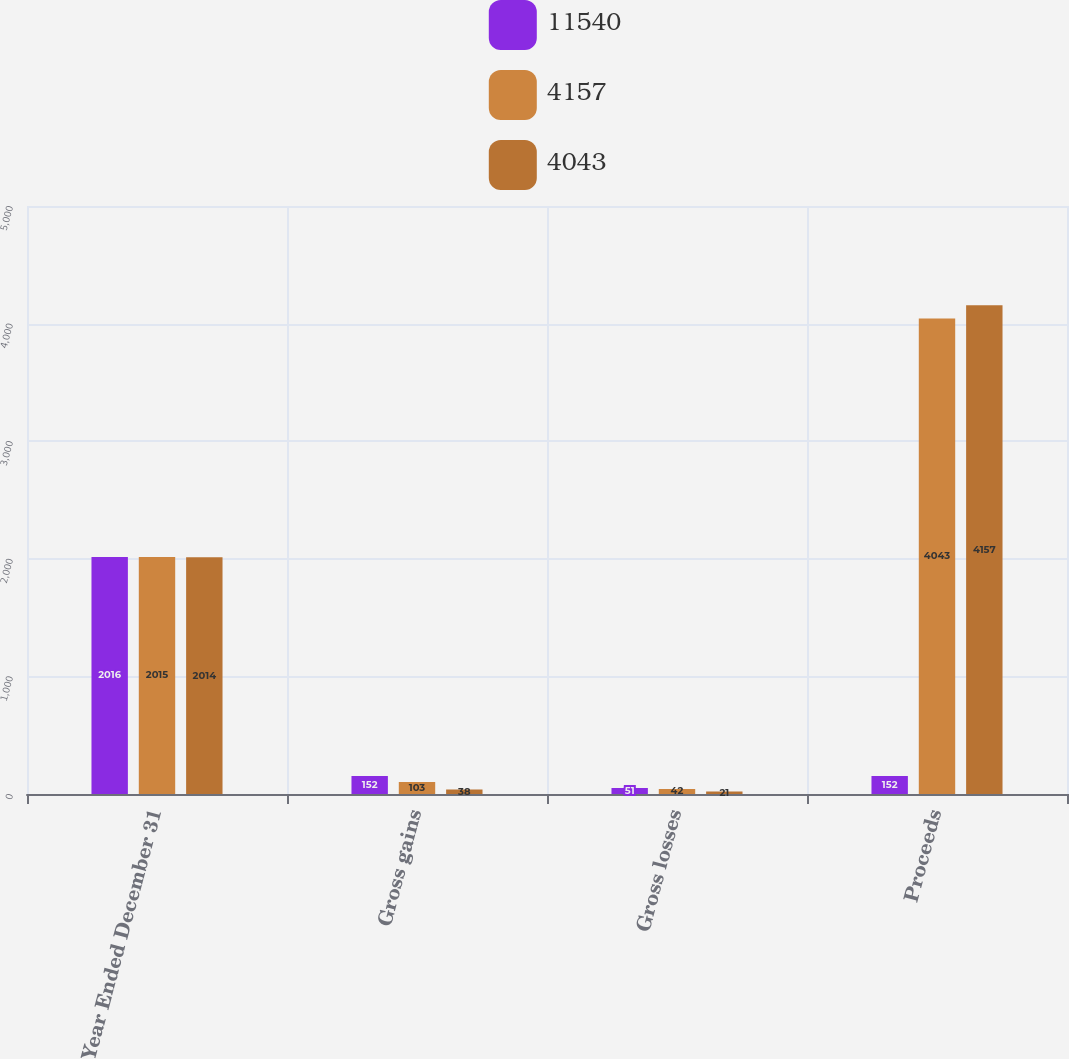Convert chart to OTSL. <chart><loc_0><loc_0><loc_500><loc_500><stacked_bar_chart><ecel><fcel>Year Ended December 31<fcel>Gross gains<fcel>Gross losses<fcel>Proceeds<nl><fcel>11540<fcel>2016<fcel>152<fcel>51<fcel>152<nl><fcel>4157<fcel>2015<fcel>103<fcel>42<fcel>4043<nl><fcel>4043<fcel>2014<fcel>38<fcel>21<fcel>4157<nl></chart> 